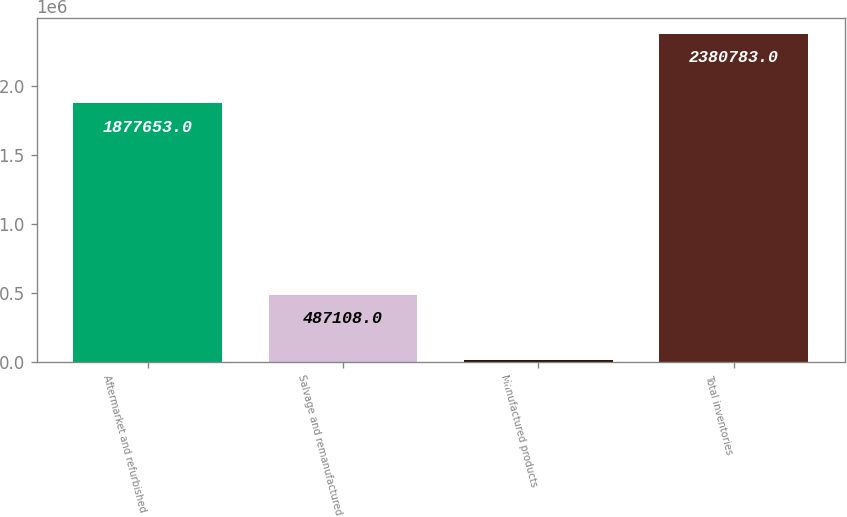Convert chart to OTSL. <chart><loc_0><loc_0><loc_500><loc_500><bar_chart><fcel>Aftermarket and refurbished<fcel>Salvage and remanufactured<fcel>Manufactured products<fcel>Total inventories<nl><fcel>1.87765e+06<fcel>487108<fcel>16022<fcel>2.38078e+06<nl></chart> 